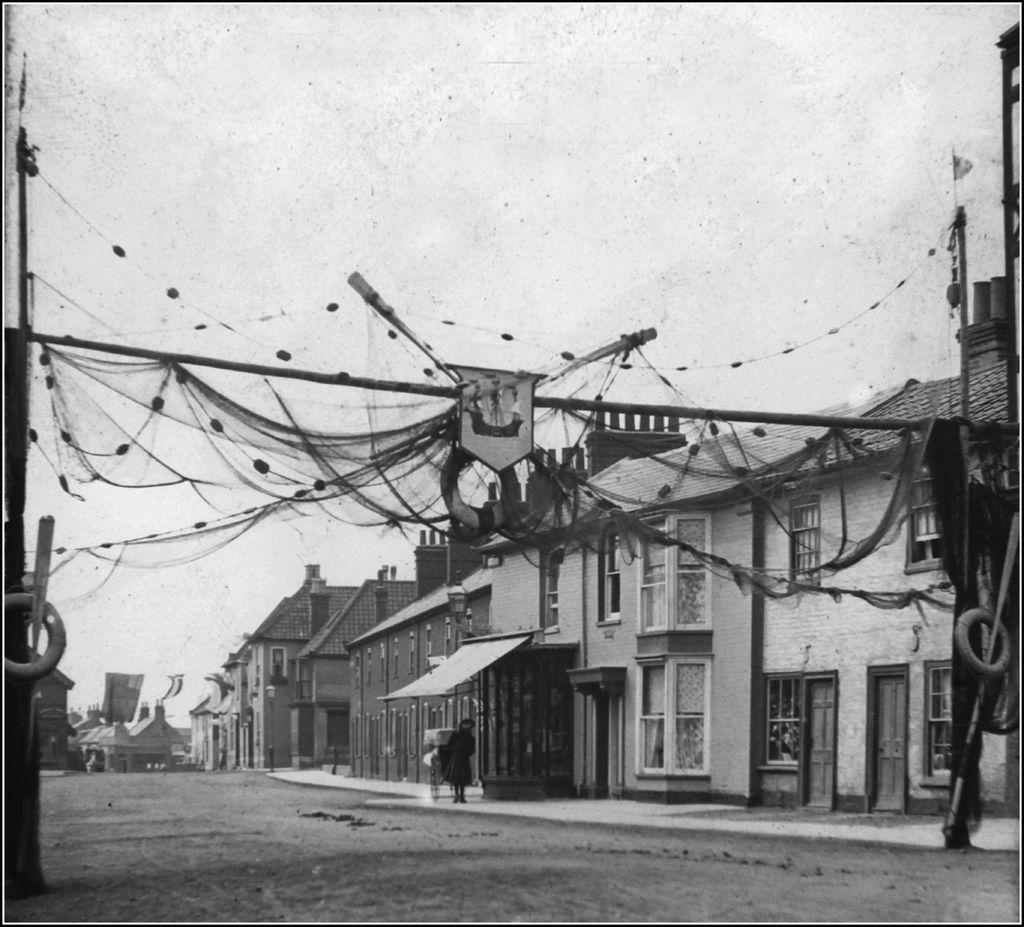What is the main subject in the center of the image? There is a person standing in the center of the image. What type of structures can be seen in the image? There are buildings in the image. What is hanging in the front of the image? There is a cloth hanging in the front of the image. How would you describe the sky in the image? The sky is cloudy in the image. How many mice are sitting on the person's shoulder in the image? There are no mice present in the image, so it is not possible to answer that question. 